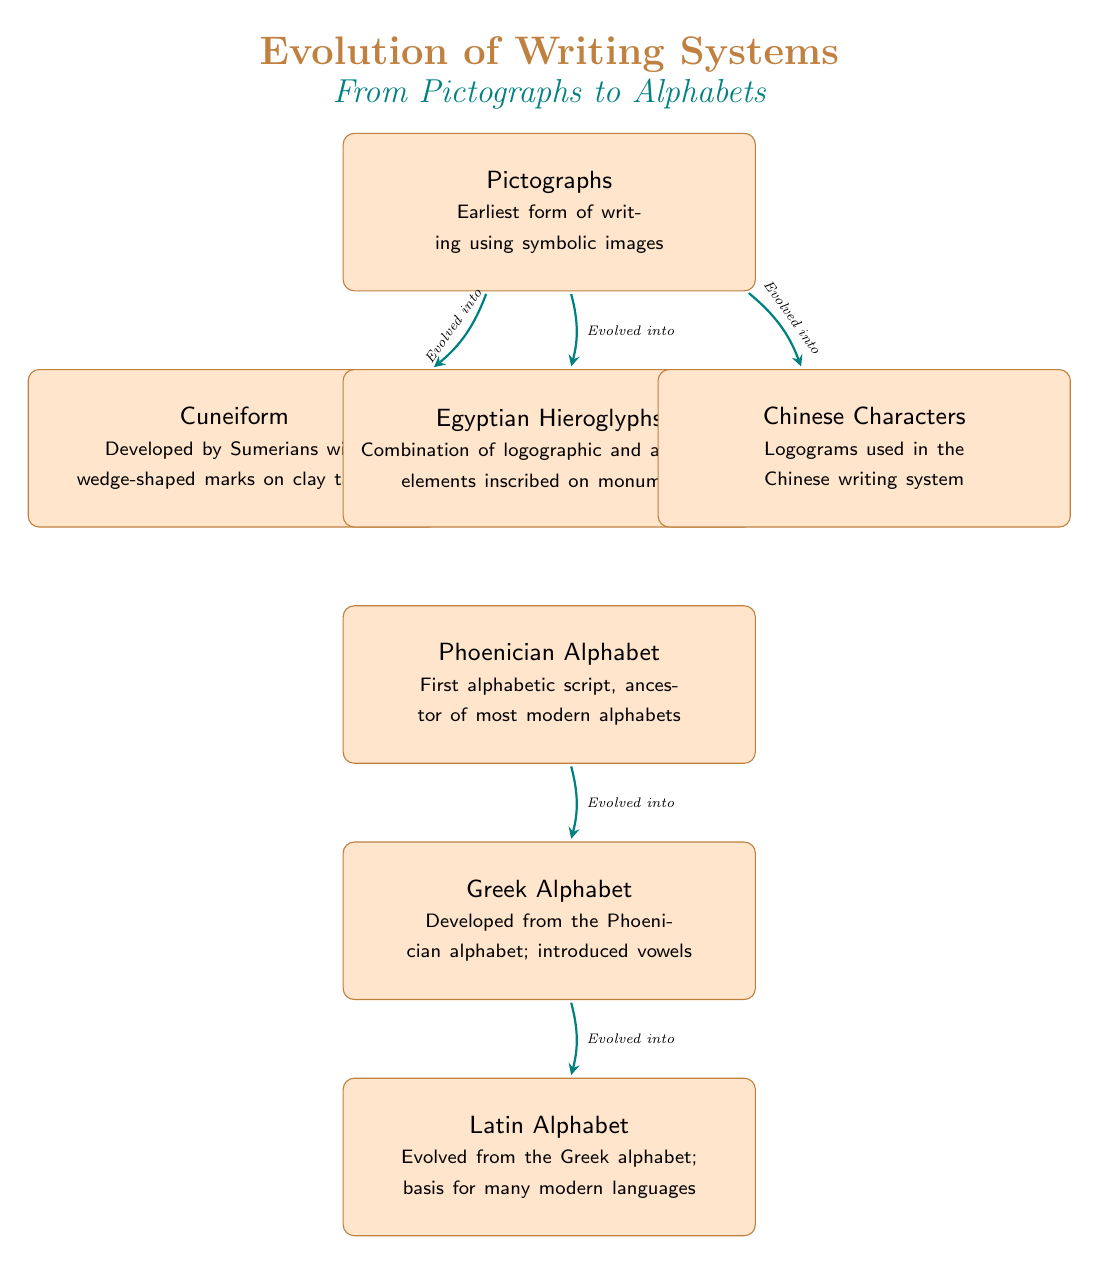What is the earliest form of writing depicted in the diagram? The diagram clearly labels the earliest form of writing as "Pictographs," and it appears at the top of the diagram.
Answer: Pictographs How many types of writing systems are shown in the diagram? The diagram includes a total of seven distinct writing systems, each represented as a labeled box.
Answer: 7 Which writing system evolved directly from Pictographs? Following the arrows in the diagram, Pictographs evolved into Cuneiform, Egyptian Hieroglyphs, and Chinese Characters. The question specifically asks for one, so Cuneiform can be given as an answer.
Answer: Cuneiform What characteristic distinguishes the Greek Alphabet in the evolution of writing? The diagram notes that the Greek Alphabet "introduced vowels," which is a significant characteristic that differentiates it from earlier scripts.
Answer: Introduced vowels From which alphabet did the Latin Alphabet evolve? According to the diagram, the Latin Alphabet evolved from the Greek Alphabet. This relationship is indicated by the directional arrow pointing from the Greek Alphabet to the Latin Alphabet.
Answer: Greek Alphabet Which writing system was developed by the Sumerians? The diagram specifies that Cuneiform was developed by the Sumerians, providing a direct association between the two.
Answer: Cuneiform What is the role of the Phoenician Alphabet in the timeline of writing systems? The diagram describes the Phoenician Alphabet as "First alphabetic script, ancestor of most modern alphabets," indicating its foundational role in the development of future writing systems.
Answer: Ancestor of most modern alphabets In which order did the writing systems evolve from Pictographs? The arrows indicate that Pictographs evolved into Cuneiform, Egyptian Hieroglyphs, and Chinese Characters. Therefore, the correct sequence is: Cuneiform, Egyptian Hieroglyphs, Chinese Characters.
Answer: Cuneiform, Egyptian Hieroglyphs, Chinese Characters Which writing system comes last in the evolution of the writing systems? The last writing system in the evolution presented in the diagram is the Latin Alphabet, positioned at the bottom of the visual flow.
Answer: Latin Alphabet 